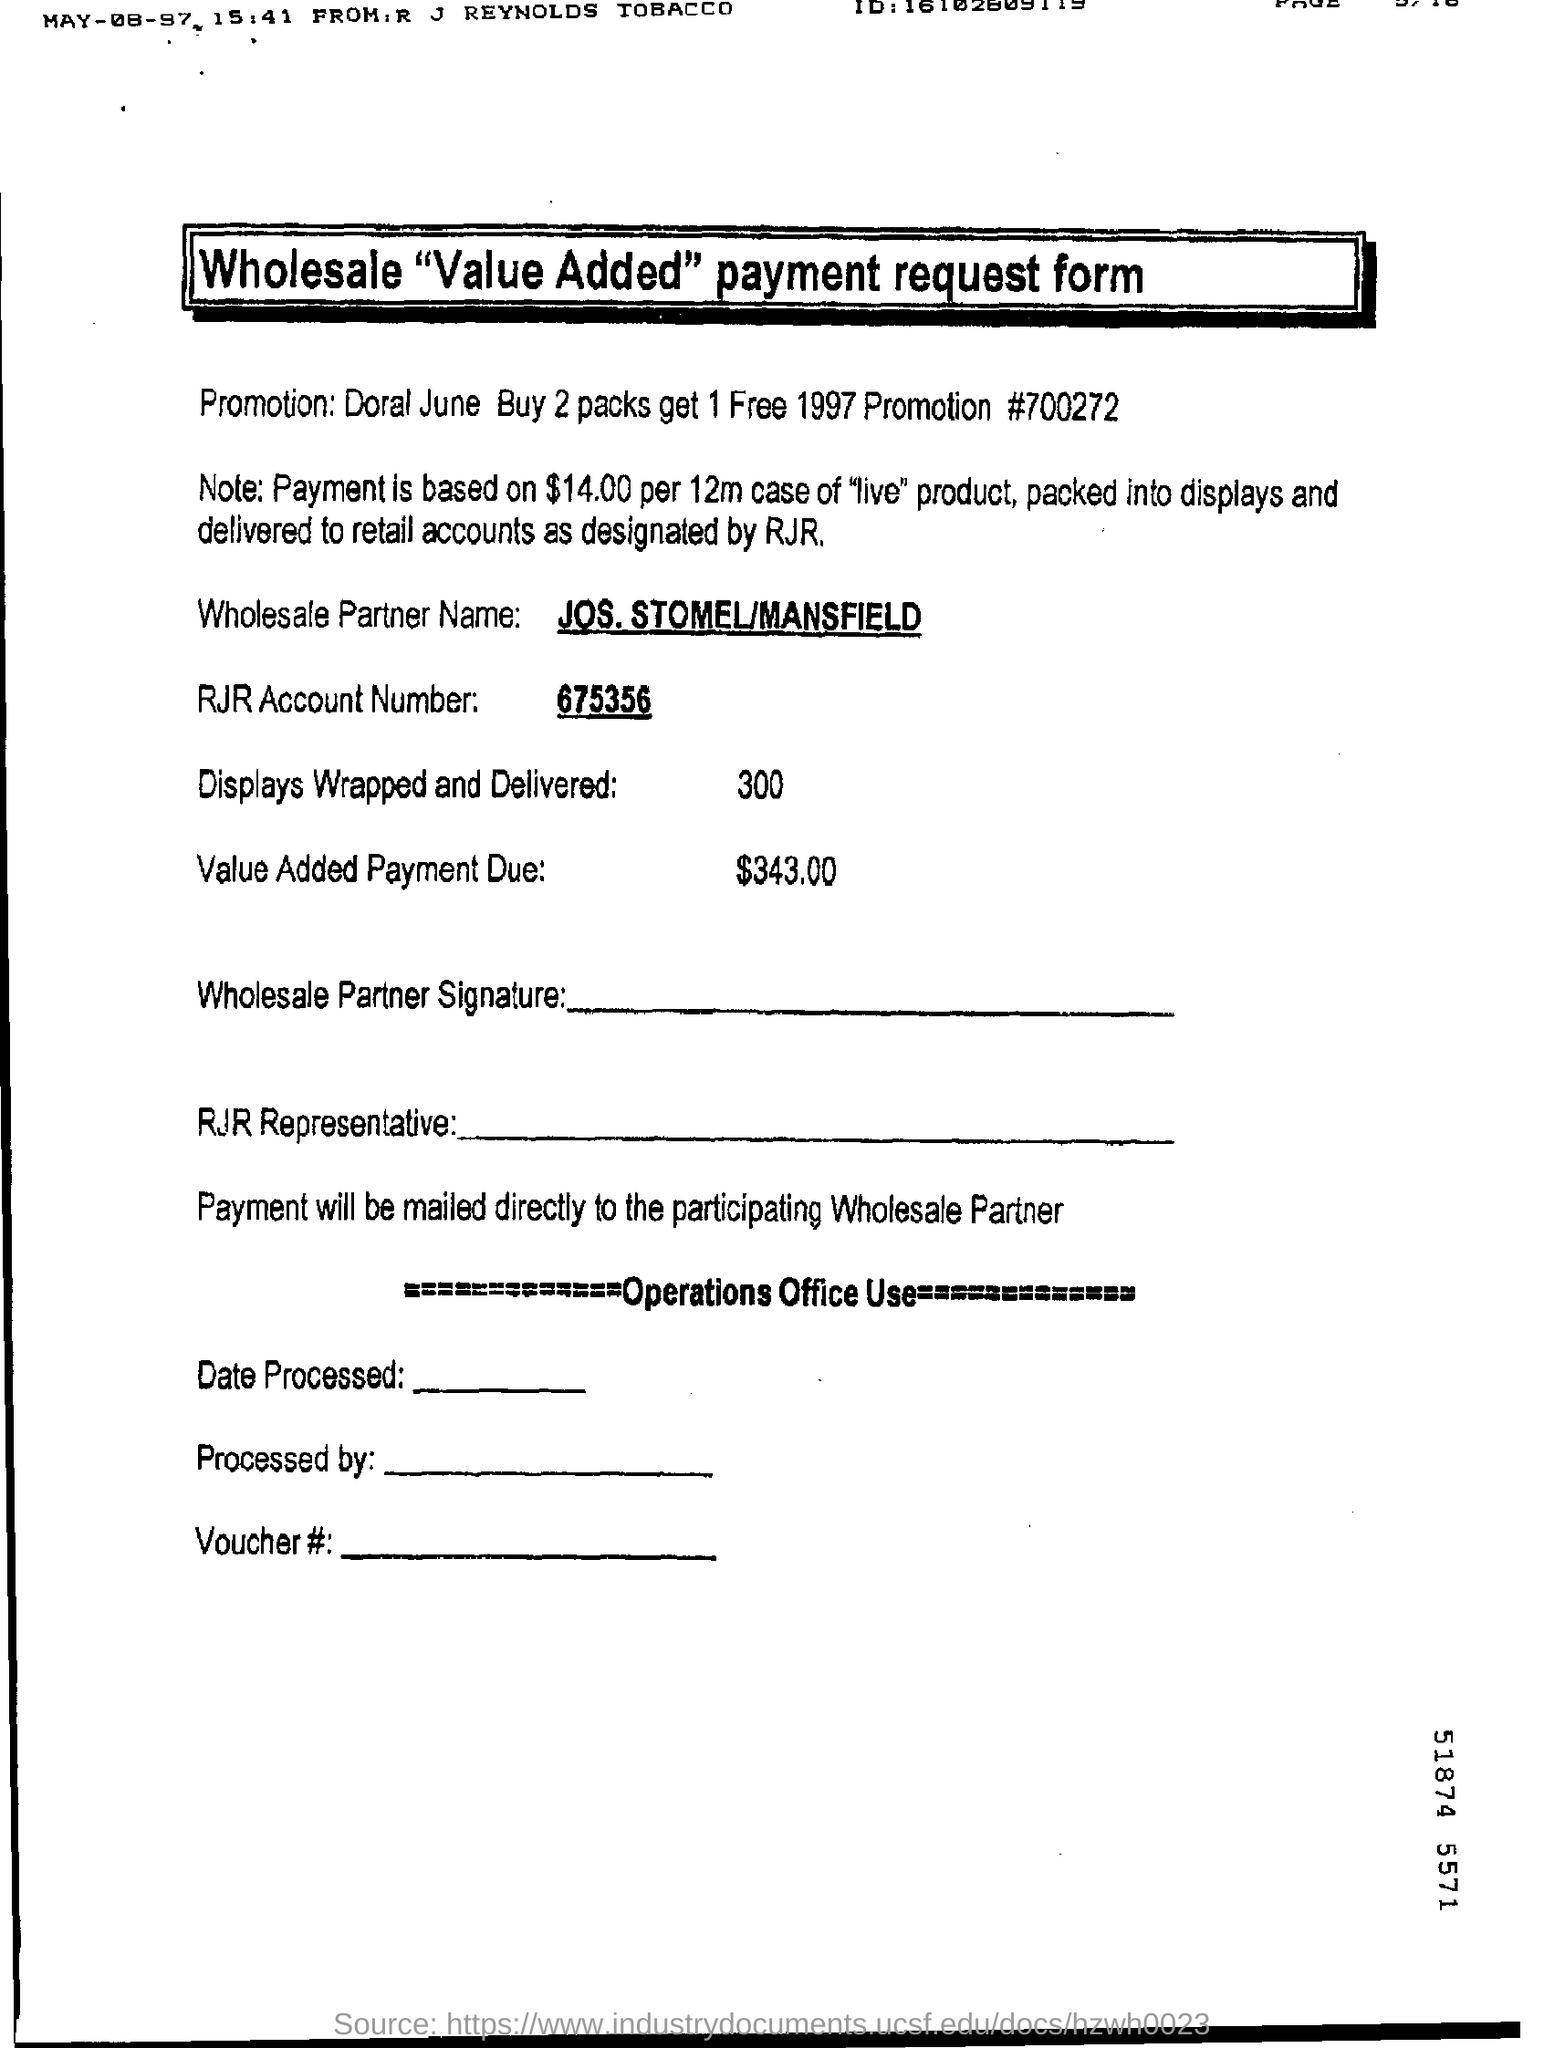Highlight a few significant elements in this photo. The title of the form is "Wholesale Value-Added Payment Request Form. What is the promotion number? It is 700272...". The value-added payment due is $343.00. The name of the wholesale partner is Jos. Stomel/Mansfield. I'm sorry, but the text you provided does not contain a question or a complete sentence. It appears to be a sequence of numbers followed by a period. Could you please provide more context or clarify your request? 